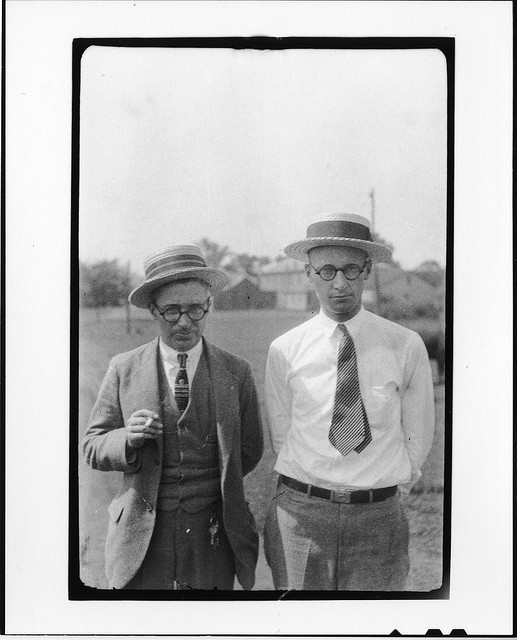<image>Who are the narrators? I don't know who the narrators are. It could be men, people, or specific individuals such as James Earl Jones or Wright. What facial expressions are the men wearing? It is uncertain what facial expressions the men are wearing. They could be smiling, solemn, serious, happy, have a straight face, be wearing glasses, or be smirking. Who are the narrators? I am not sure who the narrators are. They can be none, men, people, or James Earl Jones and Wright. What facial expressions are the men wearing? I am not sure what facial expressions the men are wearing. It can be seen smiles, solemn, serious, happy or straight face. 